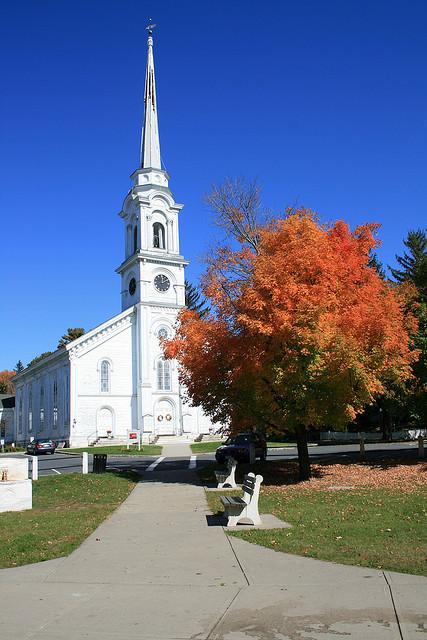Is this a church?
Give a very brief answer. Yes. What season is it?
Give a very brief answer. Fall. Are there clouds in the sky?
Concise answer only. No. Is this a religious building?
Write a very short answer. Yes. What is at the top of the tower?
Short answer required. Cross. 